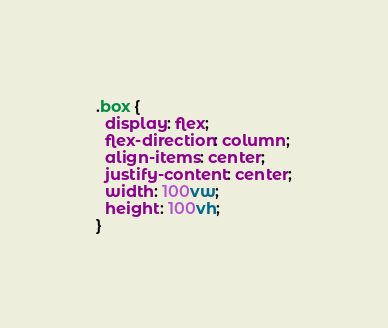<code> <loc_0><loc_0><loc_500><loc_500><_CSS_>.box {
  display: flex;
  flex-direction: column;
  align-items: center;
  justify-content: center;
  width: 100vw;
  height: 100vh;
}
</code> 